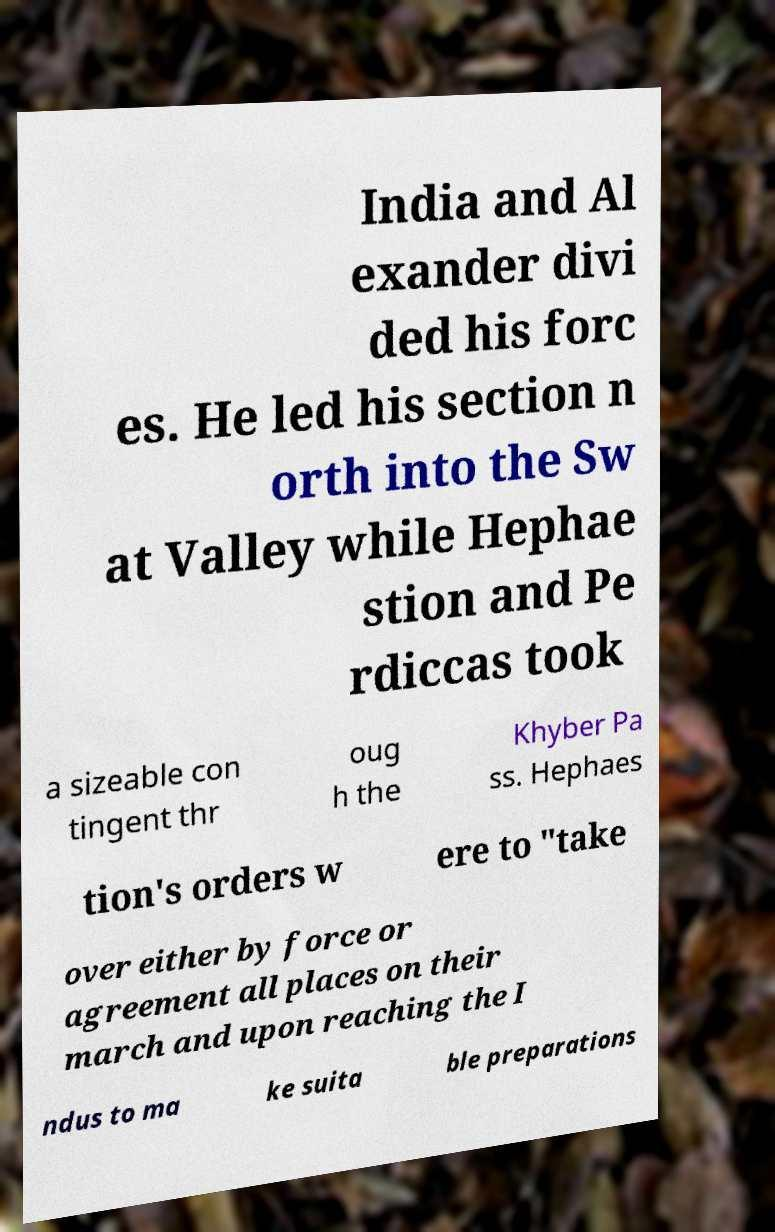For documentation purposes, I need the text within this image transcribed. Could you provide that? India and Al exander divi ded his forc es. He led his section n orth into the Sw at Valley while Hephae stion and Pe rdiccas took a sizeable con tingent thr oug h the Khyber Pa ss. Hephaes tion's orders w ere to "take over either by force or agreement all places on their march and upon reaching the I ndus to ma ke suita ble preparations 